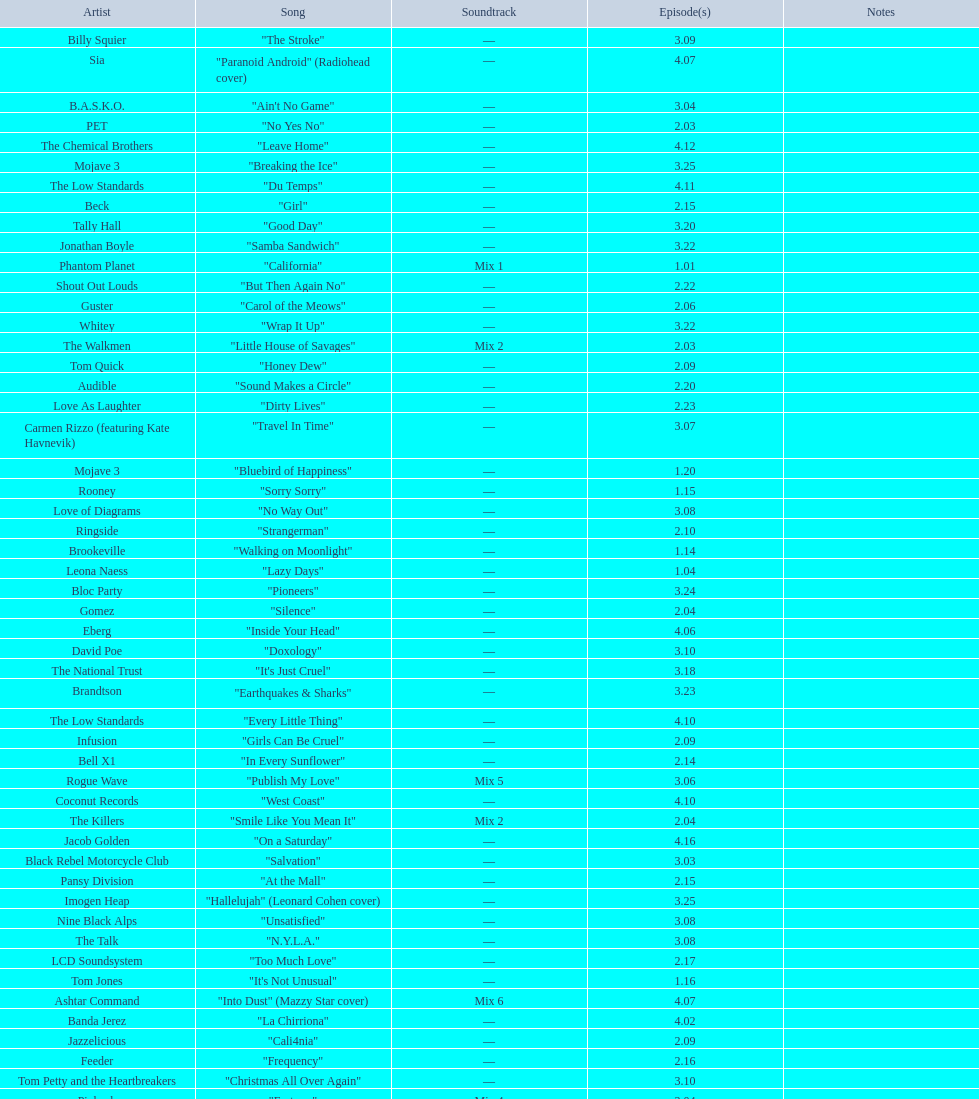What artist has more music appear in the show, daft punk or franz ferdinand? Franz Ferdinand. 